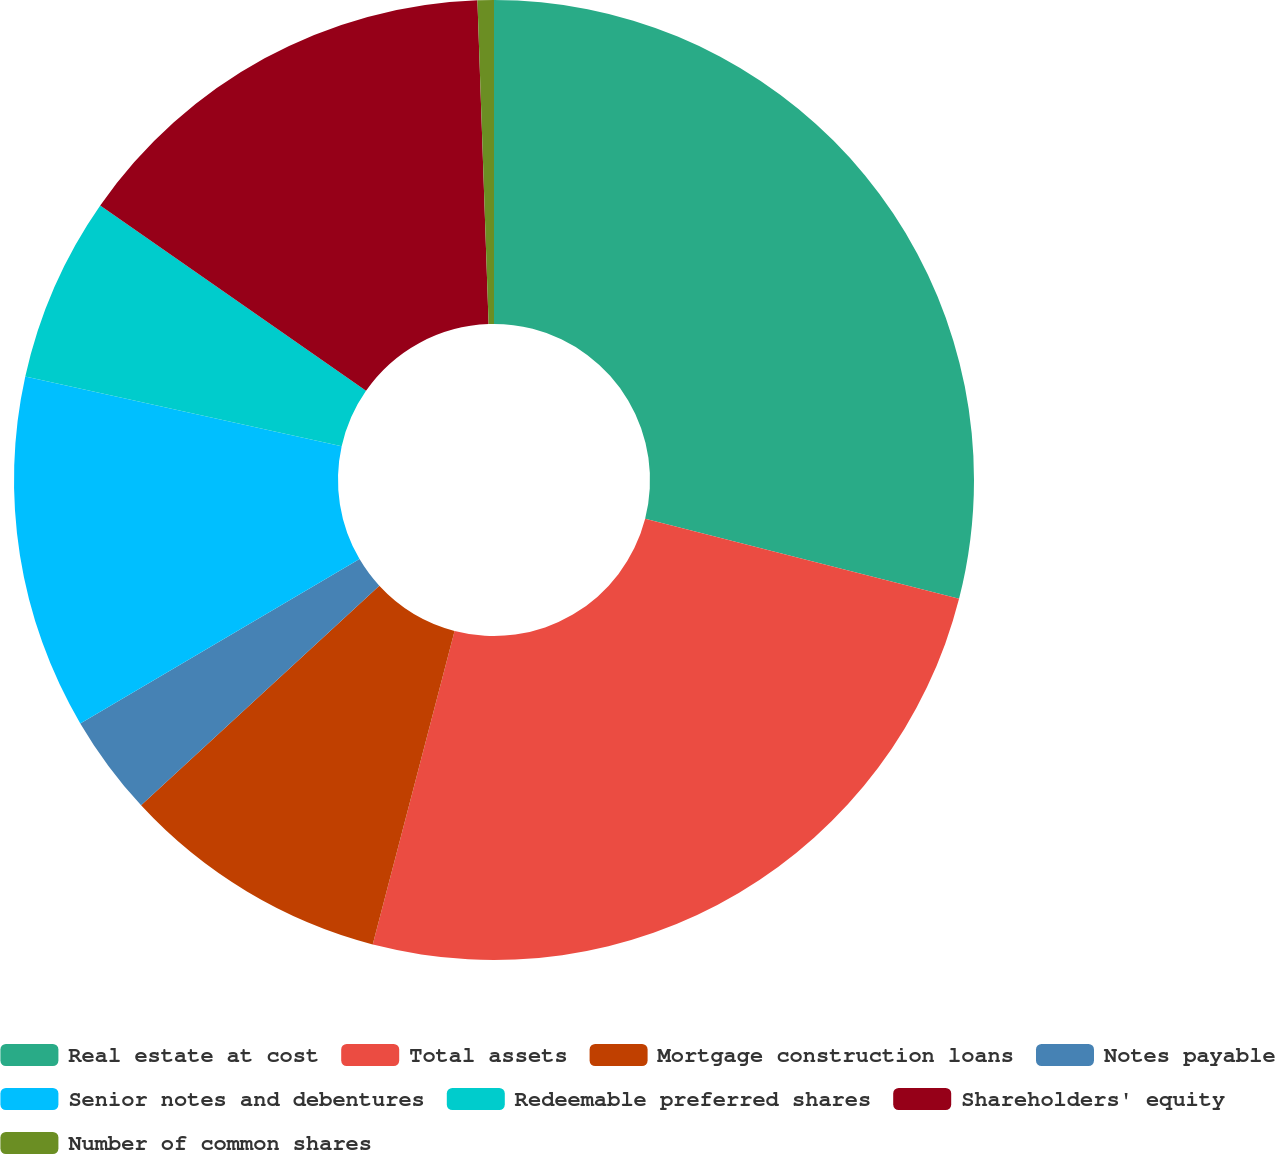Convert chart. <chart><loc_0><loc_0><loc_500><loc_500><pie_chart><fcel>Real estate at cost<fcel>Total assets<fcel>Mortgage construction loans<fcel>Notes payable<fcel>Senior notes and debentures<fcel>Redeemable preferred shares<fcel>Shareholders' equity<fcel>Number of common shares<nl><fcel>28.98%<fcel>25.08%<fcel>9.08%<fcel>3.39%<fcel>11.92%<fcel>6.23%<fcel>14.76%<fcel>0.55%<nl></chart> 